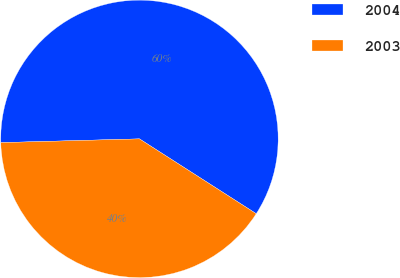Convert chart. <chart><loc_0><loc_0><loc_500><loc_500><pie_chart><fcel>2004<fcel>2003<nl><fcel>59.5%<fcel>40.5%<nl></chart> 